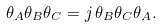<formula> <loc_0><loc_0><loc_500><loc_500>\theta _ { A } \theta _ { B } \theta _ { C } = j \, \theta _ { B } \theta _ { C } \theta _ { A } .</formula> 